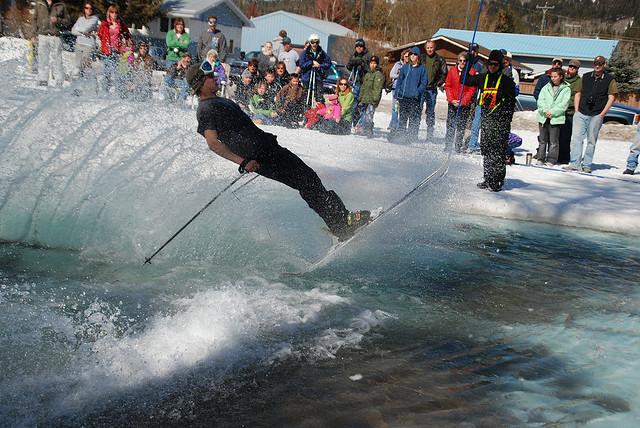What is the temperature of the water?
Keep it brief. Cold. Is this person doing something safe?
Give a very brief answer. No. Is this man rigid?
Short answer required. Yes. 